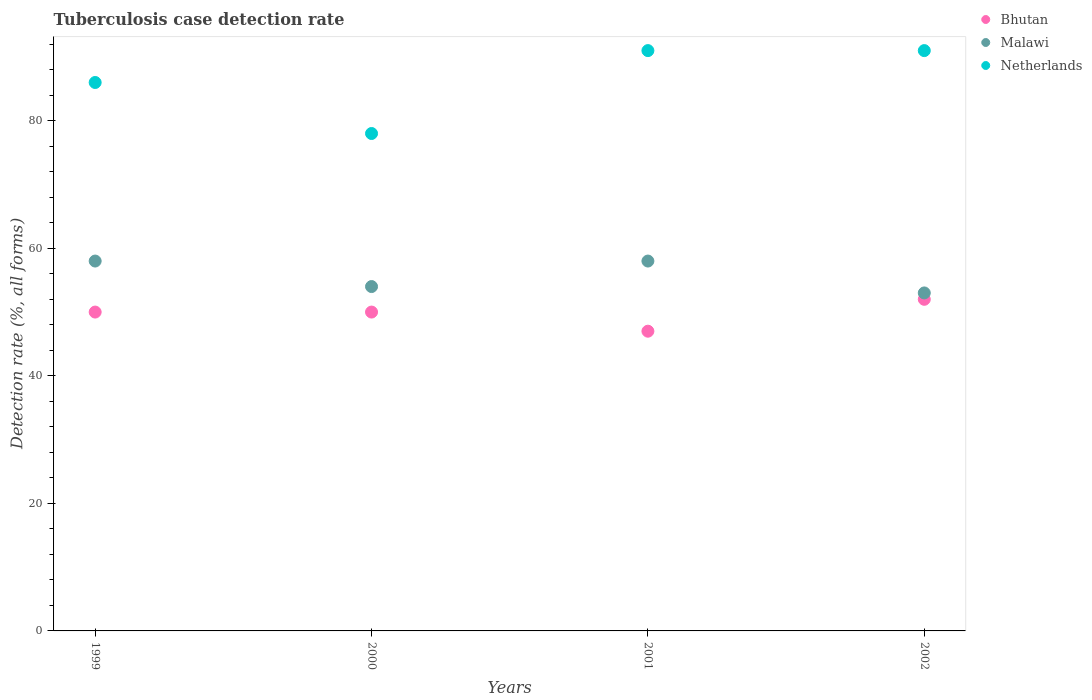How many different coloured dotlines are there?
Offer a terse response. 3. Is the number of dotlines equal to the number of legend labels?
Offer a terse response. Yes. What is the tuberculosis case detection rate in in Malawi in 2002?
Your response must be concise. 53. Across all years, what is the maximum tuberculosis case detection rate in in Bhutan?
Provide a short and direct response. 52. In which year was the tuberculosis case detection rate in in Malawi minimum?
Provide a short and direct response. 2002. What is the total tuberculosis case detection rate in in Malawi in the graph?
Your response must be concise. 223. What is the difference between the tuberculosis case detection rate in in Malawi in 2000 and that in 2001?
Provide a short and direct response. -4. What is the difference between the tuberculosis case detection rate in in Malawi in 1999 and the tuberculosis case detection rate in in Netherlands in 2001?
Provide a short and direct response. -33. What is the average tuberculosis case detection rate in in Bhutan per year?
Offer a very short reply. 49.75. In the year 2001, what is the difference between the tuberculosis case detection rate in in Bhutan and tuberculosis case detection rate in in Netherlands?
Provide a succinct answer. -44. What is the difference between the highest and the second highest tuberculosis case detection rate in in Netherlands?
Provide a short and direct response. 0. What is the difference between the highest and the lowest tuberculosis case detection rate in in Netherlands?
Provide a succinct answer. 13. In how many years, is the tuberculosis case detection rate in in Bhutan greater than the average tuberculosis case detection rate in in Bhutan taken over all years?
Your answer should be very brief. 3. Is the sum of the tuberculosis case detection rate in in Netherlands in 1999 and 2000 greater than the maximum tuberculosis case detection rate in in Bhutan across all years?
Make the answer very short. Yes. Is it the case that in every year, the sum of the tuberculosis case detection rate in in Bhutan and tuberculosis case detection rate in in Netherlands  is greater than the tuberculosis case detection rate in in Malawi?
Your answer should be very brief. Yes. Is the tuberculosis case detection rate in in Malawi strictly greater than the tuberculosis case detection rate in in Bhutan over the years?
Your answer should be compact. Yes. How many years are there in the graph?
Offer a terse response. 4. Where does the legend appear in the graph?
Your answer should be compact. Top right. How many legend labels are there?
Your answer should be very brief. 3. How are the legend labels stacked?
Keep it short and to the point. Vertical. What is the title of the graph?
Ensure brevity in your answer.  Tuberculosis case detection rate. Does "Nepal" appear as one of the legend labels in the graph?
Your answer should be very brief. No. What is the label or title of the X-axis?
Offer a terse response. Years. What is the label or title of the Y-axis?
Provide a succinct answer. Detection rate (%, all forms). What is the Detection rate (%, all forms) in Bhutan in 1999?
Offer a very short reply. 50. What is the Detection rate (%, all forms) of Netherlands in 1999?
Ensure brevity in your answer.  86. What is the Detection rate (%, all forms) in Bhutan in 2000?
Your answer should be compact. 50. What is the Detection rate (%, all forms) of Malawi in 2000?
Provide a short and direct response. 54. What is the Detection rate (%, all forms) of Bhutan in 2001?
Ensure brevity in your answer.  47. What is the Detection rate (%, all forms) of Netherlands in 2001?
Provide a short and direct response. 91. What is the Detection rate (%, all forms) in Malawi in 2002?
Offer a terse response. 53. What is the Detection rate (%, all forms) in Netherlands in 2002?
Give a very brief answer. 91. Across all years, what is the maximum Detection rate (%, all forms) in Bhutan?
Provide a short and direct response. 52. Across all years, what is the maximum Detection rate (%, all forms) of Malawi?
Give a very brief answer. 58. Across all years, what is the maximum Detection rate (%, all forms) of Netherlands?
Ensure brevity in your answer.  91. Across all years, what is the minimum Detection rate (%, all forms) of Netherlands?
Your answer should be compact. 78. What is the total Detection rate (%, all forms) in Bhutan in the graph?
Ensure brevity in your answer.  199. What is the total Detection rate (%, all forms) of Malawi in the graph?
Keep it short and to the point. 223. What is the total Detection rate (%, all forms) of Netherlands in the graph?
Ensure brevity in your answer.  346. What is the difference between the Detection rate (%, all forms) in Malawi in 1999 and that in 2000?
Your answer should be compact. 4. What is the difference between the Detection rate (%, all forms) of Netherlands in 1999 and that in 2001?
Make the answer very short. -5. What is the difference between the Detection rate (%, all forms) of Bhutan in 1999 and that in 2002?
Offer a very short reply. -2. What is the difference between the Detection rate (%, all forms) in Netherlands in 1999 and that in 2002?
Provide a succinct answer. -5. What is the difference between the Detection rate (%, all forms) in Malawi in 2000 and that in 2001?
Provide a succinct answer. -4. What is the difference between the Detection rate (%, all forms) of Bhutan in 2000 and that in 2002?
Give a very brief answer. -2. What is the difference between the Detection rate (%, all forms) of Netherlands in 2000 and that in 2002?
Offer a very short reply. -13. What is the difference between the Detection rate (%, all forms) in Netherlands in 2001 and that in 2002?
Your answer should be compact. 0. What is the difference between the Detection rate (%, all forms) of Bhutan in 1999 and the Detection rate (%, all forms) of Netherlands in 2000?
Your answer should be very brief. -28. What is the difference between the Detection rate (%, all forms) of Bhutan in 1999 and the Detection rate (%, all forms) of Netherlands in 2001?
Your answer should be compact. -41. What is the difference between the Detection rate (%, all forms) in Malawi in 1999 and the Detection rate (%, all forms) in Netherlands in 2001?
Provide a short and direct response. -33. What is the difference between the Detection rate (%, all forms) in Bhutan in 1999 and the Detection rate (%, all forms) in Malawi in 2002?
Provide a short and direct response. -3. What is the difference between the Detection rate (%, all forms) of Bhutan in 1999 and the Detection rate (%, all forms) of Netherlands in 2002?
Your response must be concise. -41. What is the difference between the Detection rate (%, all forms) of Malawi in 1999 and the Detection rate (%, all forms) of Netherlands in 2002?
Offer a terse response. -33. What is the difference between the Detection rate (%, all forms) in Bhutan in 2000 and the Detection rate (%, all forms) in Malawi in 2001?
Your response must be concise. -8. What is the difference between the Detection rate (%, all forms) in Bhutan in 2000 and the Detection rate (%, all forms) in Netherlands in 2001?
Offer a very short reply. -41. What is the difference between the Detection rate (%, all forms) in Malawi in 2000 and the Detection rate (%, all forms) in Netherlands in 2001?
Your answer should be very brief. -37. What is the difference between the Detection rate (%, all forms) of Bhutan in 2000 and the Detection rate (%, all forms) of Netherlands in 2002?
Make the answer very short. -41. What is the difference between the Detection rate (%, all forms) in Malawi in 2000 and the Detection rate (%, all forms) in Netherlands in 2002?
Keep it short and to the point. -37. What is the difference between the Detection rate (%, all forms) of Bhutan in 2001 and the Detection rate (%, all forms) of Malawi in 2002?
Your answer should be very brief. -6. What is the difference between the Detection rate (%, all forms) in Bhutan in 2001 and the Detection rate (%, all forms) in Netherlands in 2002?
Keep it short and to the point. -44. What is the difference between the Detection rate (%, all forms) of Malawi in 2001 and the Detection rate (%, all forms) of Netherlands in 2002?
Your answer should be compact. -33. What is the average Detection rate (%, all forms) in Bhutan per year?
Your answer should be compact. 49.75. What is the average Detection rate (%, all forms) of Malawi per year?
Offer a terse response. 55.75. What is the average Detection rate (%, all forms) of Netherlands per year?
Give a very brief answer. 86.5. In the year 1999, what is the difference between the Detection rate (%, all forms) in Bhutan and Detection rate (%, all forms) in Netherlands?
Provide a short and direct response. -36. In the year 2000, what is the difference between the Detection rate (%, all forms) of Bhutan and Detection rate (%, all forms) of Netherlands?
Keep it short and to the point. -28. In the year 2001, what is the difference between the Detection rate (%, all forms) of Bhutan and Detection rate (%, all forms) of Malawi?
Your response must be concise. -11. In the year 2001, what is the difference between the Detection rate (%, all forms) in Bhutan and Detection rate (%, all forms) in Netherlands?
Keep it short and to the point. -44. In the year 2001, what is the difference between the Detection rate (%, all forms) of Malawi and Detection rate (%, all forms) of Netherlands?
Ensure brevity in your answer.  -33. In the year 2002, what is the difference between the Detection rate (%, all forms) of Bhutan and Detection rate (%, all forms) of Malawi?
Ensure brevity in your answer.  -1. In the year 2002, what is the difference between the Detection rate (%, all forms) in Bhutan and Detection rate (%, all forms) in Netherlands?
Ensure brevity in your answer.  -39. In the year 2002, what is the difference between the Detection rate (%, all forms) in Malawi and Detection rate (%, all forms) in Netherlands?
Your answer should be compact. -38. What is the ratio of the Detection rate (%, all forms) of Malawi in 1999 to that in 2000?
Provide a short and direct response. 1.07. What is the ratio of the Detection rate (%, all forms) of Netherlands in 1999 to that in 2000?
Your response must be concise. 1.1. What is the ratio of the Detection rate (%, all forms) in Bhutan in 1999 to that in 2001?
Keep it short and to the point. 1.06. What is the ratio of the Detection rate (%, all forms) of Netherlands in 1999 to that in 2001?
Keep it short and to the point. 0.95. What is the ratio of the Detection rate (%, all forms) of Bhutan in 1999 to that in 2002?
Give a very brief answer. 0.96. What is the ratio of the Detection rate (%, all forms) in Malawi in 1999 to that in 2002?
Keep it short and to the point. 1.09. What is the ratio of the Detection rate (%, all forms) of Netherlands in 1999 to that in 2002?
Give a very brief answer. 0.95. What is the ratio of the Detection rate (%, all forms) of Bhutan in 2000 to that in 2001?
Give a very brief answer. 1.06. What is the ratio of the Detection rate (%, all forms) in Malawi in 2000 to that in 2001?
Your answer should be very brief. 0.93. What is the ratio of the Detection rate (%, all forms) of Bhutan in 2000 to that in 2002?
Your answer should be compact. 0.96. What is the ratio of the Detection rate (%, all forms) of Malawi in 2000 to that in 2002?
Your answer should be compact. 1.02. What is the ratio of the Detection rate (%, all forms) in Netherlands in 2000 to that in 2002?
Keep it short and to the point. 0.86. What is the ratio of the Detection rate (%, all forms) in Bhutan in 2001 to that in 2002?
Offer a very short reply. 0.9. What is the ratio of the Detection rate (%, all forms) in Malawi in 2001 to that in 2002?
Provide a succinct answer. 1.09. What is the difference between the highest and the lowest Detection rate (%, all forms) of Malawi?
Offer a terse response. 5. What is the difference between the highest and the lowest Detection rate (%, all forms) of Netherlands?
Offer a very short reply. 13. 